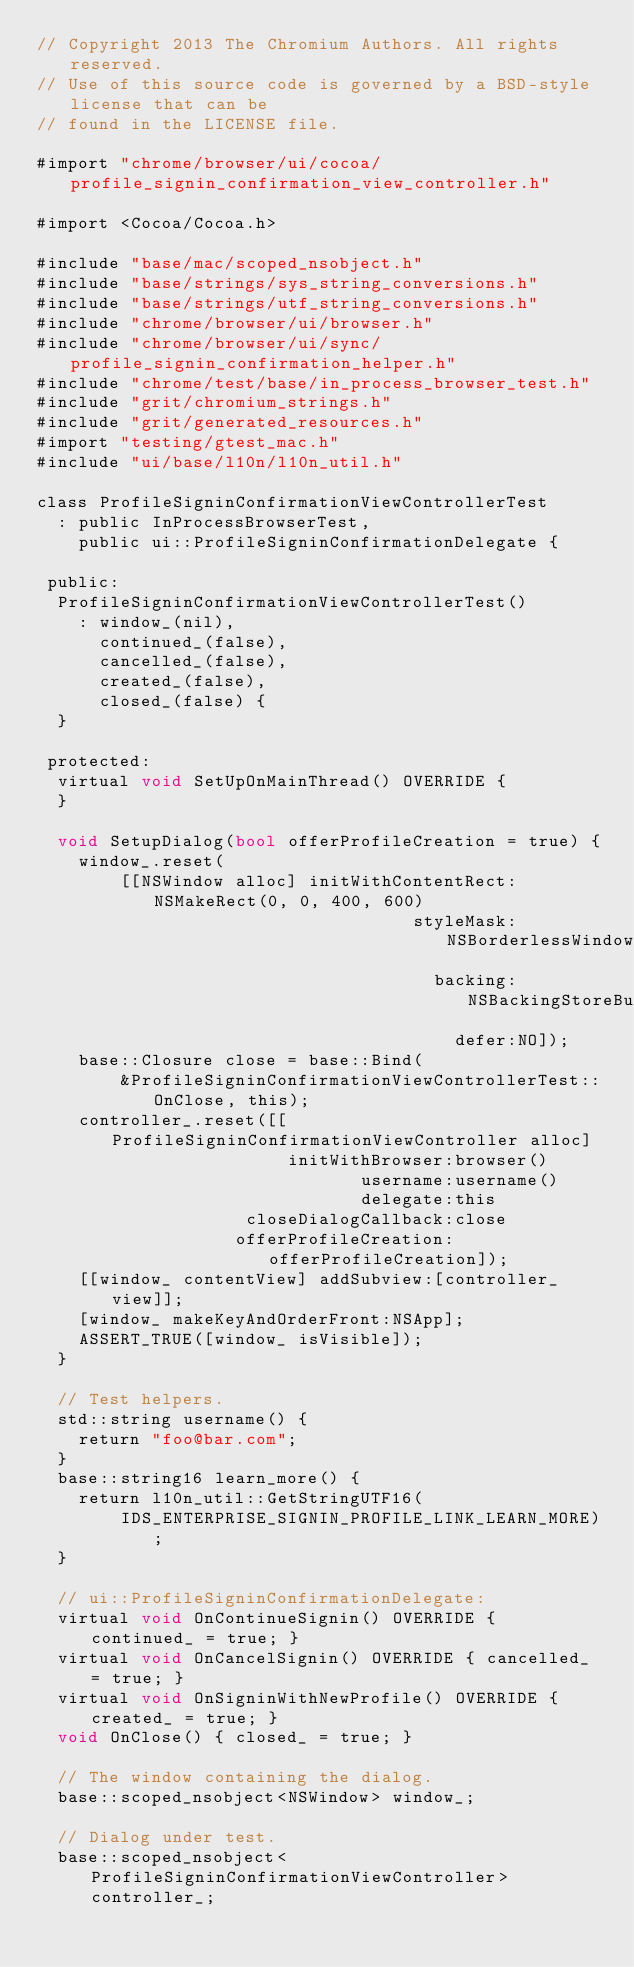<code> <loc_0><loc_0><loc_500><loc_500><_ObjectiveC_>// Copyright 2013 The Chromium Authors. All rights reserved.
// Use of this source code is governed by a BSD-style license that can be
// found in the LICENSE file.

#import "chrome/browser/ui/cocoa/profile_signin_confirmation_view_controller.h"

#import <Cocoa/Cocoa.h>

#include "base/mac/scoped_nsobject.h"
#include "base/strings/sys_string_conversions.h"
#include "base/strings/utf_string_conversions.h"
#include "chrome/browser/ui/browser.h"
#include "chrome/browser/ui/sync/profile_signin_confirmation_helper.h"
#include "chrome/test/base/in_process_browser_test.h"
#include "grit/chromium_strings.h"
#include "grit/generated_resources.h"
#import "testing/gtest_mac.h"
#include "ui/base/l10n/l10n_util.h"

class ProfileSigninConfirmationViewControllerTest
  : public InProcessBrowserTest,
    public ui::ProfileSigninConfirmationDelegate {

 public:
  ProfileSigninConfirmationViewControllerTest()
    : window_(nil),
      continued_(false),
      cancelled_(false),
      created_(false),
      closed_(false) {
  }

 protected:
  virtual void SetUpOnMainThread() OVERRIDE {
  }

  void SetupDialog(bool offerProfileCreation = true) {
    window_.reset(
        [[NSWindow alloc] initWithContentRect:NSMakeRect(0, 0, 400, 600)
                                    styleMask:NSBorderlessWindowMask
                                      backing:NSBackingStoreBuffered
                                        defer:NO]);
    base::Closure close = base::Bind(
        &ProfileSigninConfirmationViewControllerTest::OnClose, this);
    controller_.reset([[ProfileSigninConfirmationViewController alloc]
                        initWithBrowser:browser()
                               username:username()
                               delegate:this
                    closeDialogCallback:close
                   offerProfileCreation:offerProfileCreation]);
    [[window_ contentView] addSubview:[controller_ view]];
    [window_ makeKeyAndOrderFront:NSApp];
    ASSERT_TRUE([window_ isVisible]);
  }

  // Test helpers.
  std::string username() {
    return "foo@bar.com";
  }
  base::string16 learn_more() {
    return l10n_util::GetStringUTF16(
        IDS_ENTERPRISE_SIGNIN_PROFILE_LINK_LEARN_MORE);
  }

  // ui::ProfileSigninConfirmationDelegate:
  virtual void OnContinueSignin() OVERRIDE { continued_ = true; }
  virtual void OnCancelSignin() OVERRIDE { cancelled_ = true; }
  virtual void OnSigninWithNewProfile() OVERRIDE { created_ = true; }
  void OnClose() { closed_ = true; }

  // The window containing the dialog.
  base::scoped_nsobject<NSWindow> window_;

  // Dialog under test.
  base::scoped_nsobject<ProfileSigninConfirmationViewController> controller_;
</code> 